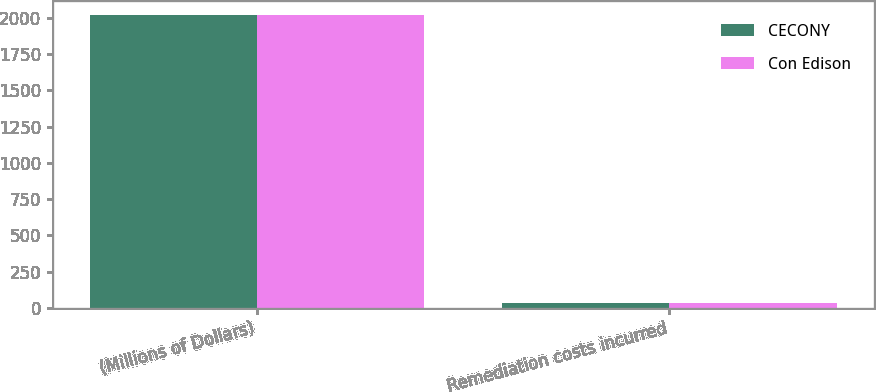Convert chart to OTSL. <chart><loc_0><loc_0><loc_500><loc_500><stacked_bar_chart><ecel><fcel>(Millions of Dollars)<fcel>Remediation costs incurred<nl><fcel>CECONY<fcel>2015<fcel>37<nl><fcel>Con Edison<fcel>2015<fcel>34<nl></chart> 